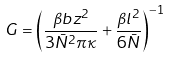<formula> <loc_0><loc_0><loc_500><loc_500>G = \left ( \frac { \beta b z ^ { 2 } } { 3 \bar { N } ^ { 2 } \pi \kappa } + \frac { \beta l ^ { 2 } } { 6 \bar { N } } \right ) ^ { - 1 }</formula> 